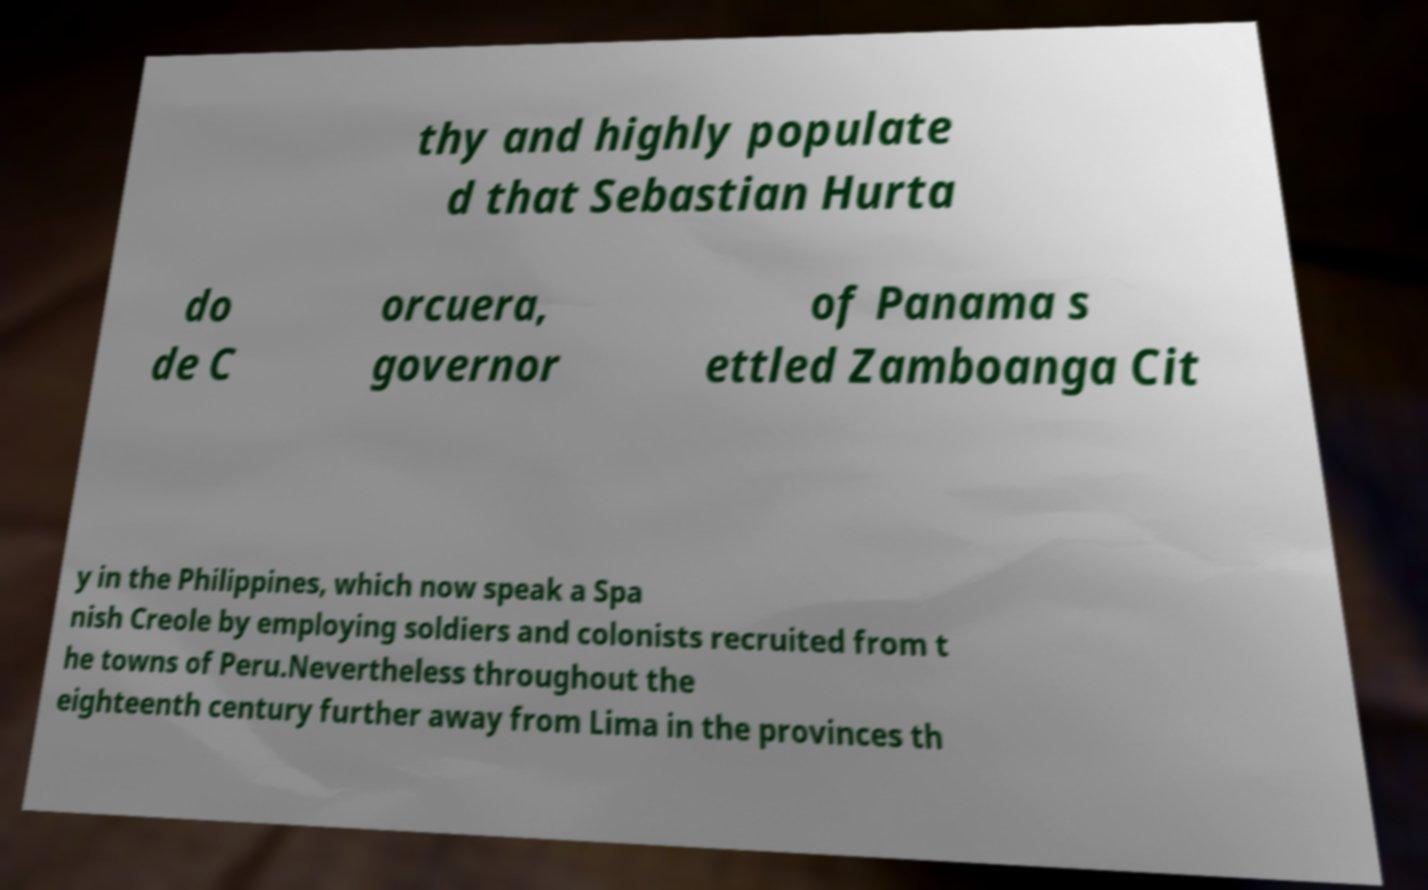There's text embedded in this image that I need extracted. Can you transcribe it verbatim? thy and highly populate d that Sebastian Hurta do de C orcuera, governor of Panama s ettled Zamboanga Cit y in the Philippines, which now speak a Spa nish Creole by employing soldiers and colonists recruited from t he towns of Peru.Nevertheless throughout the eighteenth century further away from Lima in the provinces th 